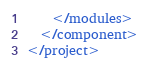<code> <loc_0><loc_0><loc_500><loc_500><_XML_>    </modules>
  </component>
</project></code> 